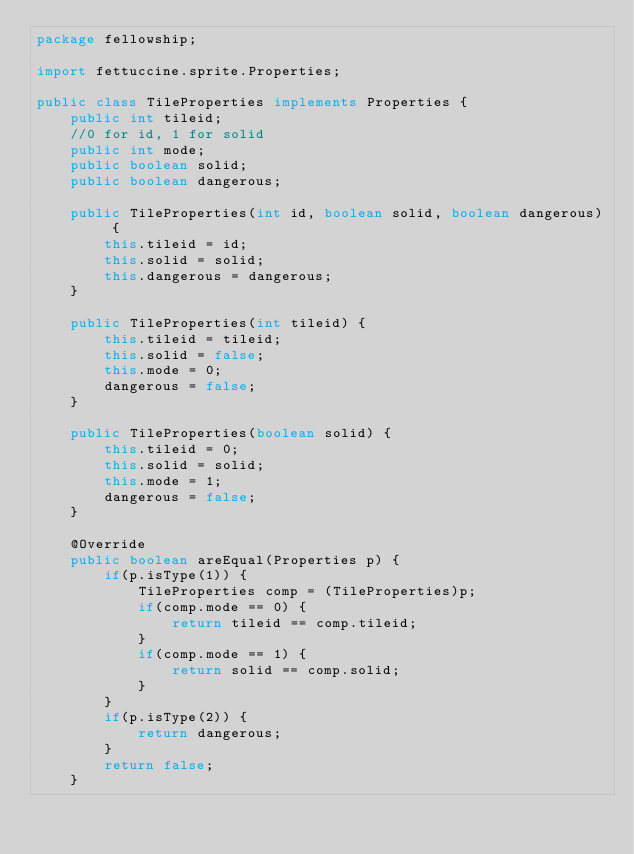<code> <loc_0><loc_0><loc_500><loc_500><_Java_>package fellowship;

import fettuccine.sprite.Properties;

public class TileProperties implements Properties {
    public int tileid;
    //0 for id, 1 for solid
    public int mode;
    public boolean solid;
    public boolean dangerous;

    public TileProperties(int id, boolean solid, boolean dangerous) {
        this.tileid = id;
        this.solid = solid;
        this.dangerous = dangerous;
    }
    
    public TileProperties(int tileid) {
        this.tileid = tileid;
        this.solid = false;
        this.mode = 0;
        dangerous = false;
    }
    
    public TileProperties(boolean solid) {
        this.tileid = 0;
        this.solid = solid;
        this.mode = 1;
        dangerous = false;
    }
    
    @Override
    public boolean areEqual(Properties p) {     
        if(p.isType(1)) {
            TileProperties comp = (TileProperties)p;
            if(comp.mode == 0) {
                return tileid == comp.tileid;
            }
            if(comp.mode == 1) {
                return solid == comp.solid;
            }
        }
        if(p.isType(2)) {
            return dangerous;
        }
        return false;
    }
</code> 